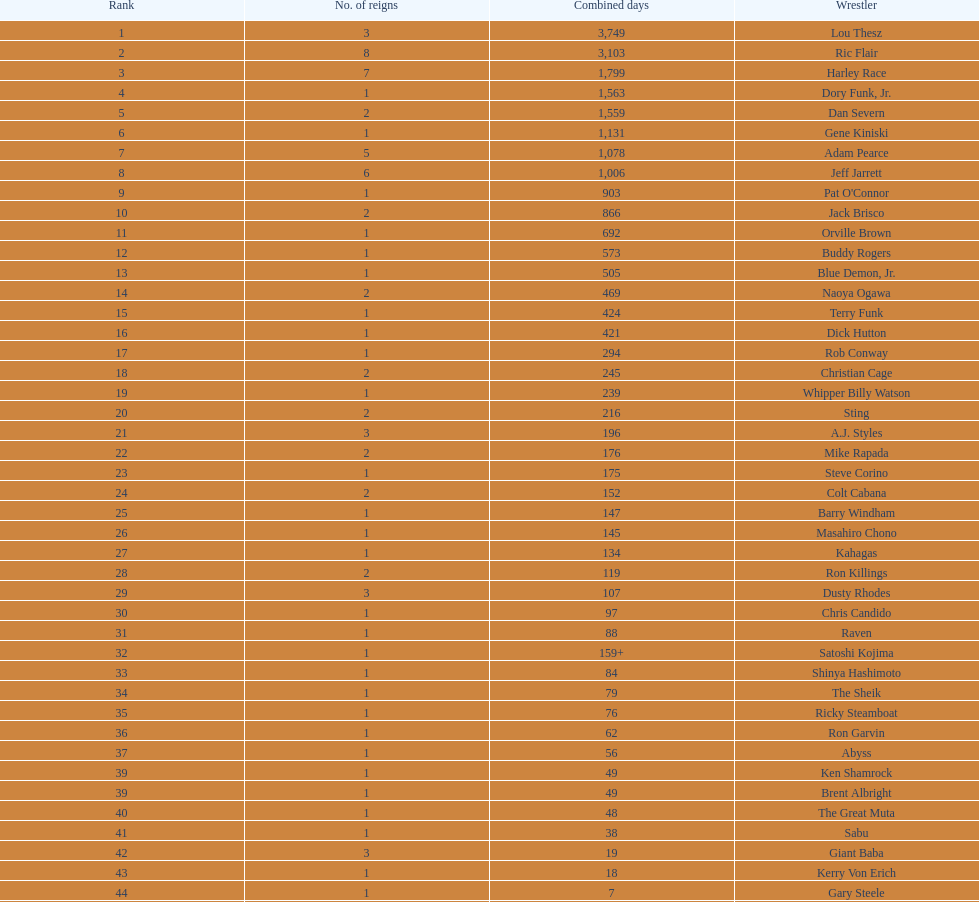Which professional wrestler has had the most number of reigns as nwa world heavyweight champion? Ric Flair. I'm looking to parse the entire table for insights. Could you assist me with that? {'header': ['Rank', 'No. of reigns', 'Combined days', 'Wrestler'], 'rows': [['1', '3', '3,749', 'Lou Thesz'], ['2', '8', '3,103', 'Ric Flair'], ['3', '7', '1,799', 'Harley Race'], ['4', '1', '1,563', 'Dory Funk, Jr.'], ['5', '2', '1,559', 'Dan Severn'], ['6', '1', '1,131', 'Gene Kiniski'], ['7', '5', '1,078', 'Adam Pearce'], ['8', '6', '1,006', 'Jeff Jarrett'], ['9', '1', '903', "Pat O'Connor"], ['10', '2', '866', 'Jack Brisco'], ['11', '1', '692', 'Orville Brown'], ['12', '1', '573', 'Buddy Rogers'], ['13', '1', '505', 'Blue Demon, Jr.'], ['14', '2', '469', 'Naoya Ogawa'], ['15', '1', '424', 'Terry Funk'], ['16', '1', '421', 'Dick Hutton'], ['17', '1', '294', 'Rob Conway'], ['18', '2', '245', 'Christian Cage'], ['19', '1', '239', 'Whipper Billy Watson'], ['20', '2', '216', 'Sting'], ['21', '3', '196', 'A.J. Styles'], ['22', '2', '176', 'Mike Rapada'], ['23', '1', '175', 'Steve Corino'], ['24', '2', '152', 'Colt Cabana'], ['25', '1', '147', 'Barry Windham'], ['26', '1', '145', 'Masahiro Chono'], ['27', '1', '134', 'Kahagas'], ['28', '2', '119', 'Ron Killings'], ['29', '3', '107', 'Dusty Rhodes'], ['30', '1', '97', 'Chris Candido'], ['31', '1', '88', 'Raven'], ['32', '1', '159+', 'Satoshi Kojima'], ['33', '1', '84', 'Shinya Hashimoto'], ['34', '1', '79', 'The Sheik'], ['35', '1', '76', 'Ricky Steamboat'], ['36', '1', '62', 'Ron Garvin'], ['37', '1', '56', 'Abyss'], ['39', '1', '49', 'Ken Shamrock'], ['39', '1', '49', 'Brent Albright'], ['40', '1', '48', 'The Great Muta'], ['41', '1', '38', 'Sabu'], ['42', '3', '19', 'Giant Baba'], ['43', '1', '18', 'Kerry Von Erich'], ['44', '1', '7', 'Gary Steele'], ['45', '1', '4', 'Tommy Rich'], ['46', '1', '2', 'Rhino'], ['47', '1', '<1', 'Shane Douglas']]} 